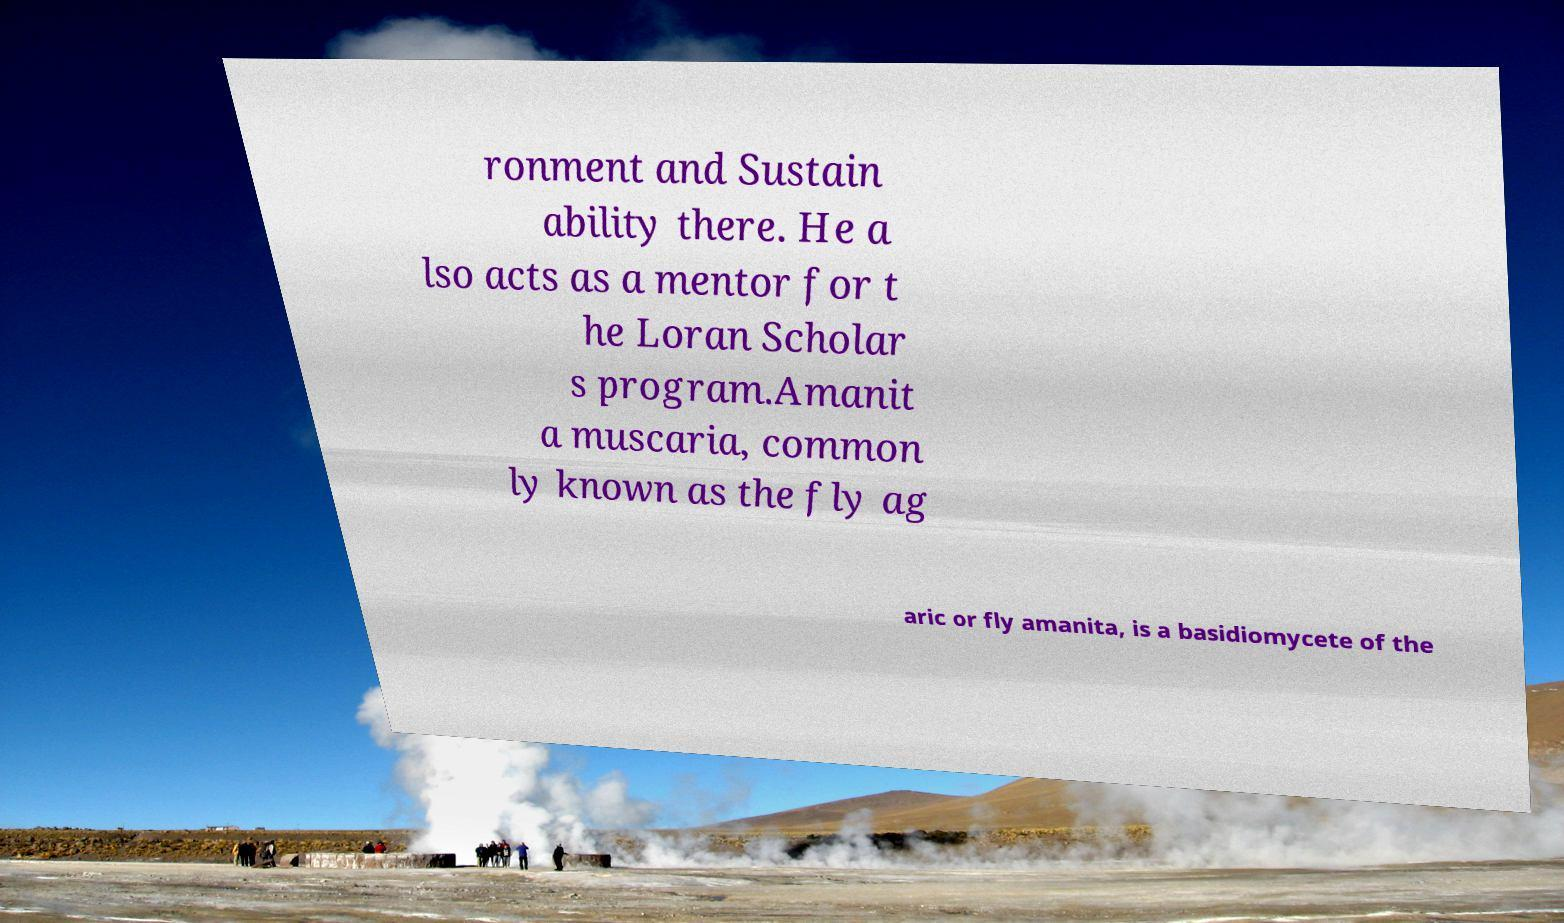Could you assist in decoding the text presented in this image and type it out clearly? ronment and Sustain ability there. He a lso acts as a mentor for t he Loran Scholar s program.Amanit a muscaria, common ly known as the fly ag aric or fly amanita, is a basidiomycete of the 